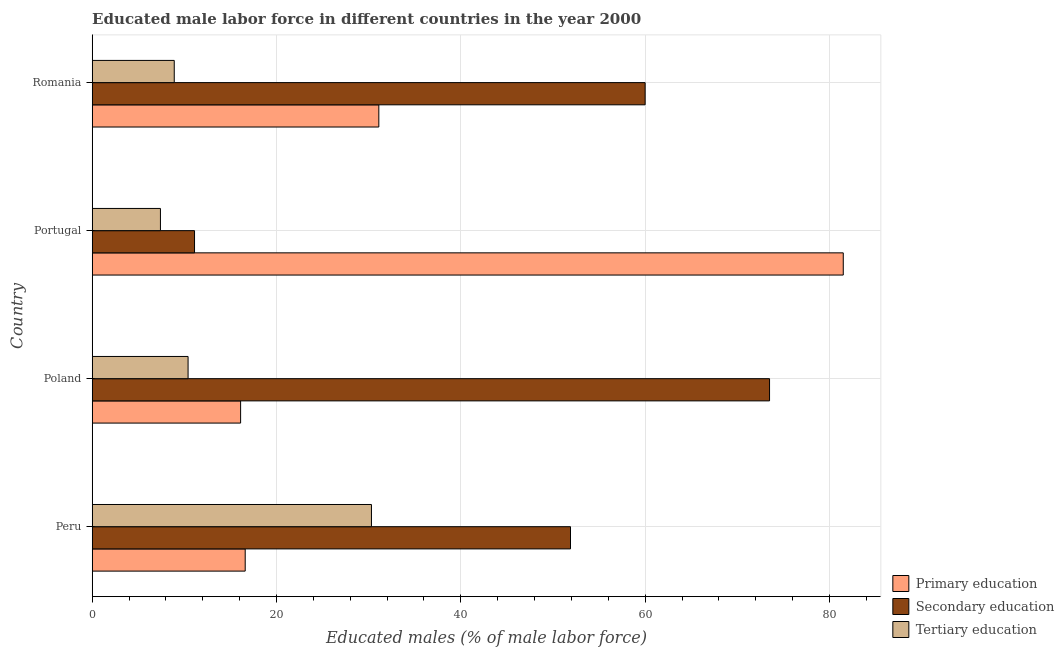How many different coloured bars are there?
Your answer should be compact. 3. Are the number of bars on each tick of the Y-axis equal?
Your answer should be very brief. Yes. What is the label of the 1st group of bars from the top?
Offer a terse response. Romania. In how many cases, is the number of bars for a given country not equal to the number of legend labels?
Your answer should be very brief. 0. What is the percentage of male labor force who received tertiary education in Poland?
Your answer should be compact. 10.4. Across all countries, what is the maximum percentage of male labor force who received secondary education?
Provide a short and direct response. 73.5. Across all countries, what is the minimum percentage of male labor force who received primary education?
Offer a very short reply. 16.1. What is the total percentage of male labor force who received secondary education in the graph?
Provide a succinct answer. 196.5. What is the difference between the percentage of male labor force who received secondary education in Poland and that in Romania?
Make the answer very short. 13.5. What is the difference between the percentage of male labor force who received secondary education in Romania and the percentage of male labor force who received primary education in Peru?
Make the answer very short. 43.4. What is the average percentage of male labor force who received tertiary education per country?
Your answer should be very brief. 14.25. What is the difference between the percentage of male labor force who received tertiary education and percentage of male labor force who received primary education in Portugal?
Your response must be concise. -74.1. What is the ratio of the percentage of male labor force who received secondary education in Poland to that in Portugal?
Your answer should be very brief. 6.62. What is the difference between the highest and the second highest percentage of male labor force who received secondary education?
Keep it short and to the point. 13.5. What is the difference between the highest and the lowest percentage of male labor force who received primary education?
Provide a short and direct response. 65.4. In how many countries, is the percentage of male labor force who received primary education greater than the average percentage of male labor force who received primary education taken over all countries?
Keep it short and to the point. 1. Is the sum of the percentage of male labor force who received primary education in Peru and Portugal greater than the maximum percentage of male labor force who received secondary education across all countries?
Offer a very short reply. Yes. What does the 2nd bar from the top in Portugal represents?
Your response must be concise. Secondary education. What does the 3rd bar from the bottom in Poland represents?
Make the answer very short. Tertiary education. Is it the case that in every country, the sum of the percentage of male labor force who received primary education and percentage of male labor force who received secondary education is greater than the percentage of male labor force who received tertiary education?
Provide a succinct answer. Yes. How many bars are there?
Ensure brevity in your answer.  12. How many countries are there in the graph?
Your answer should be compact. 4. Are the values on the major ticks of X-axis written in scientific E-notation?
Your answer should be compact. No. Does the graph contain grids?
Give a very brief answer. Yes. Where does the legend appear in the graph?
Your answer should be compact. Bottom right. What is the title of the graph?
Give a very brief answer. Educated male labor force in different countries in the year 2000. What is the label or title of the X-axis?
Offer a terse response. Educated males (% of male labor force). What is the label or title of the Y-axis?
Your response must be concise. Country. What is the Educated males (% of male labor force) in Primary education in Peru?
Your response must be concise. 16.6. What is the Educated males (% of male labor force) in Secondary education in Peru?
Offer a very short reply. 51.9. What is the Educated males (% of male labor force) in Tertiary education in Peru?
Keep it short and to the point. 30.3. What is the Educated males (% of male labor force) in Primary education in Poland?
Your answer should be compact. 16.1. What is the Educated males (% of male labor force) in Secondary education in Poland?
Your answer should be very brief. 73.5. What is the Educated males (% of male labor force) in Tertiary education in Poland?
Ensure brevity in your answer.  10.4. What is the Educated males (% of male labor force) in Primary education in Portugal?
Make the answer very short. 81.5. What is the Educated males (% of male labor force) of Secondary education in Portugal?
Provide a short and direct response. 11.1. What is the Educated males (% of male labor force) of Tertiary education in Portugal?
Provide a succinct answer. 7.4. What is the Educated males (% of male labor force) of Primary education in Romania?
Your answer should be very brief. 31.1. What is the Educated males (% of male labor force) of Secondary education in Romania?
Your answer should be compact. 60. What is the Educated males (% of male labor force) in Tertiary education in Romania?
Your answer should be compact. 8.9. Across all countries, what is the maximum Educated males (% of male labor force) of Primary education?
Your response must be concise. 81.5. Across all countries, what is the maximum Educated males (% of male labor force) in Secondary education?
Your response must be concise. 73.5. Across all countries, what is the maximum Educated males (% of male labor force) in Tertiary education?
Your answer should be compact. 30.3. Across all countries, what is the minimum Educated males (% of male labor force) in Primary education?
Your answer should be very brief. 16.1. Across all countries, what is the minimum Educated males (% of male labor force) in Secondary education?
Keep it short and to the point. 11.1. Across all countries, what is the minimum Educated males (% of male labor force) of Tertiary education?
Offer a terse response. 7.4. What is the total Educated males (% of male labor force) of Primary education in the graph?
Keep it short and to the point. 145.3. What is the total Educated males (% of male labor force) in Secondary education in the graph?
Offer a terse response. 196.5. What is the total Educated males (% of male labor force) of Tertiary education in the graph?
Give a very brief answer. 57. What is the difference between the Educated males (% of male labor force) in Secondary education in Peru and that in Poland?
Offer a terse response. -21.6. What is the difference between the Educated males (% of male labor force) of Tertiary education in Peru and that in Poland?
Provide a short and direct response. 19.9. What is the difference between the Educated males (% of male labor force) of Primary education in Peru and that in Portugal?
Provide a succinct answer. -64.9. What is the difference between the Educated males (% of male labor force) of Secondary education in Peru and that in Portugal?
Provide a short and direct response. 40.8. What is the difference between the Educated males (% of male labor force) of Tertiary education in Peru and that in Portugal?
Offer a very short reply. 22.9. What is the difference between the Educated males (% of male labor force) in Secondary education in Peru and that in Romania?
Ensure brevity in your answer.  -8.1. What is the difference between the Educated males (% of male labor force) in Tertiary education in Peru and that in Romania?
Your answer should be compact. 21.4. What is the difference between the Educated males (% of male labor force) in Primary education in Poland and that in Portugal?
Provide a short and direct response. -65.4. What is the difference between the Educated males (% of male labor force) in Secondary education in Poland and that in Portugal?
Offer a terse response. 62.4. What is the difference between the Educated males (% of male labor force) in Tertiary education in Poland and that in Portugal?
Provide a succinct answer. 3. What is the difference between the Educated males (% of male labor force) of Primary education in Poland and that in Romania?
Offer a very short reply. -15. What is the difference between the Educated males (% of male labor force) in Secondary education in Poland and that in Romania?
Offer a very short reply. 13.5. What is the difference between the Educated males (% of male labor force) in Tertiary education in Poland and that in Romania?
Your answer should be very brief. 1.5. What is the difference between the Educated males (% of male labor force) of Primary education in Portugal and that in Romania?
Provide a succinct answer. 50.4. What is the difference between the Educated males (% of male labor force) in Secondary education in Portugal and that in Romania?
Provide a short and direct response. -48.9. What is the difference between the Educated males (% of male labor force) of Tertiary education in Portugal and that in Romania?
Your answer should be very brief. -1.5. What is the difference between the Educated males (% of male labor force) in Primary education in Peru and the Educated males (% of male labor force) in Secondary education in Poland?
Your answer should be very brief. -56.9. What is the difference between the Educated males (% of male labor force) of Primary education in Peru and the Educated males (% of male labor force) of Tertiary education in Poland?
Your response must be concise. 6.2. What is the difference between the Educated males (% of male labor force) of Secondary education in Peru and the Educated males (% of male labor force) of Tertiary education in Poland?
Keep it short and to the point. 41.5. What is the difference between the Educated males (% of male labor force) in Primary education in Peru and the Educated males (% of male labor force) in Tertiary education in Portugal?
Keep it short and to the point. 9.2. What is the difference between the Educated males (% of male labor force) of Secondary education in Peru and the Educated males (% of male labor force) of Tertiary education in Portugal?
Offer a terse response. 44.5. What is the difference between the Educated males (% of male labor force) in Primary education in Peru and the Educated males (% of male labor force) in Secondary education in Romania?
Keep it short and to the point. -43.4. What is the difference between the Educated males (% of male labor force) of Primary education in Poland and the Educated males (% of male labor force) of Secondary education in Portugal?
Your answer should be compact. 5. What is the difference between the Educated males (% of male labor force) of Secondary education in Poland and the Educated males (% of male labor force) of Tertiary education in Portugal?
Make the answer very short. 66.1. What is the difference between the Educated males (% of male labor force) in Primary education in Poland and the Educated males (% of male labor force) in Secondary education in Romania?
Ensure brevity in your answer.  -43.9. What is the difference between the Educated males (% of male labor force) of Primary education in Poland and the Educated males (% of male labor force) of Tertiary education in Romania?
Provide a succinct answer. 7.2. What is the difference between the Educated males (% of male labor force) in Secondary education in Poland and the Educated males (% of male labor force) in Tertiary education in Romania?
Provide a succinct answer. 64.6. What is the difference between the Educated males (% of male labor force) in Primary education in Portugal and the Educated males (% of male labor force) in Secondary education in Romania?
Provide a succinct answer. 21.5. What is the difference between the Educated males (% of male labor force) of Primary education in Portugal and the Educated males (% of male labor force) of Tertiary education in Romania?
Offer a terse response. 72.6. What is the difference between the Educated males (% of male labor force) of Secondary education in Portugal and the Educated males (% of male labor force) of Tertiary education in Romania?
Your answer should be compact. 2.2. What is the average Educated males (% of male labor force) in Primary education per country?
Make the answer very short. 36.33. What is the average Educated males (% of male labor force) of Secondary education per country?
Keep it short and to the point. 49.12. What is the average Educated males (% of male labor force) in Tertiary education per country?
Keep it short and to the point. 14.25. What is the difference between the Educated males (% of male labor force) of Primary education and Educated males (% of male labor force) of Secondary education in Peru?
Provide a short and direct response. -35.3. What is the difference between the Educated males (% of male labor force) in Primary education and Educated males (% of male labor force) in Tertiary education in Peru?
Your answer should be very brief. -13.7. What is the difference between the Educated males (% of male labor force) in Secondary education and Educated males (% of male labor force) in Tertiary education in Peru?
Provide a succinct answer. 21.6. What is the difference between the Educated males (% of male labor force) of Primary education and Educated males (% of male labor force) of Secondary education in Poland?
Keep it short and to the point. -57.4. What is the difference between the Educated males (% of male labor force) of Secondary education and Educated males (% of male labor force) of Tertiary education in Poland?
Provide a short and direct response. 63.1. What is the difference between the Educated males (% of male labor force) of Primary education and Educated males (% of male labor force) of Secondary education in Portugal?
Make the answer very short. 70.4. What is the difference between the Educated males (% of male labor force) of Primary education and Educated males (% of male labor force) of Tertiary education in Portugal?
Make the answer very short. 74.1. What is the difference between the Educated males (% of male labor force) in Secondary education and Educated males (% of male labor force) in Tertiary education in Portugal?
Your answer should be compact. 3.7. What is the difference between the Educated males (% of male labor force) of Primary education and Educated males (% of male labor force) of Secondary education in Romania?
Provide a short and direct response. -28.9. What is the difference between the Educated males (% of male labor force) in Secondary education and Educated males (% of male labor force) in Tertiary education in Romania?
Your response must be concise. 51.1. What is the ratio of the Educated males (% of male labor force) in Primary education in Peru to that in Poland?
Provide a succinct answer. 1.03. What is the ratio of the Educated males (% of male labor force) in Secondary education in Peru to that in Poland?
Give a very brief answer. 0.71. What is the ratio of the Educated males (% of male labor force) in Tertiary education in Peru to that in Poland?
Offer a very short reply. 2.91. What is the ratio of the Educated males (% of male labor force) of Primary education in Peru to that in Portugal?
Keep it short and to the point. 0.2. What is the ratio of the Educated males (% of male labor force) in Secondary education in Peru to that in Portugal?
Offer a terse response. 4.68. What is the ratio of the Educated males (% of male labor force) of Tertiary education in Peru to that in Portugal?
Provide a succinct answer. 4.09. What is the ratio of the Educated males (% of male labor force) in Primary education in Peru to that in Romania?
Your answer should be very brief. 0.53. What is the ratio of the Educated males (% of male labor force) in Secondary education in Peru to that in Romania?
Make the answer very short. 0.86. What is the ratio of the Educated males (% of male labor force) of Tertiary education in Peru to that in Romania?
Your answer should be compact. 3.4. What is the ratio of the Educated males (% of male labor force) of Primary education in Poland to that in Portugal?
Keep it short and to the point. 0.2. What is the ratio of the Educated males (% of male labor force) of Secondary education in Poland to that in Portugal?
Your answer should be compact. 6.62. What is the ratio of the Educated males (% of male labor force) in Tertiary education in Poland to that in Portugal?
Offer a very short reply. 1.41. What is the ratio of the Educated males (% of male labor force) of Primary education in Poland to that in Romania?
Your answer should be very brief. 0.52. What is the ratio of the Educated males (% of male labor force) of Secondary education in Poland to that in Romania?
Keep it short and to the point. 1.23. What is the ratio of the Educated males (% of male labor force) of Tertiary education in Poland to that in Romania?
Keep it short and to the point. 1.17. What is the ratio of the Educated males (% of male labor force) in Primary education in Portugal to that in Romania?
Give a very brief answer. 2.62. What is the ratio of the Educated males (% of male labor force) in Secondary education in Portugal to that in Romania?
Your response must be concise. 0.18. What is the ratio of the Educated males (% of male labor force) in Tertiary education in Portugal to that in Romania?
Keep it short and to the point. 0.83. What is the difference between the highest and the second highest Educated males (% of male labor force) of Primary education?
Provide a short and direct response. 50.4. What is the difference between the highest and the second highest Educated males (% of male labor force) in Tertiary education?
Your response must be concise. 19.9. What is the difference between the highest and the lowest Educated males (% of male labor force) in Primary education?
Provide a short and direct response. 65.4. What is the difference between the highest and the lowest Educated males (% of male labor force) in Secondary education?
Give a very brief answer. 62.4. What is the difference between the highest and the lowest Educated males (% of male labor force) in Tertiary education?
Ensure brevity in your answer.  22.9. 